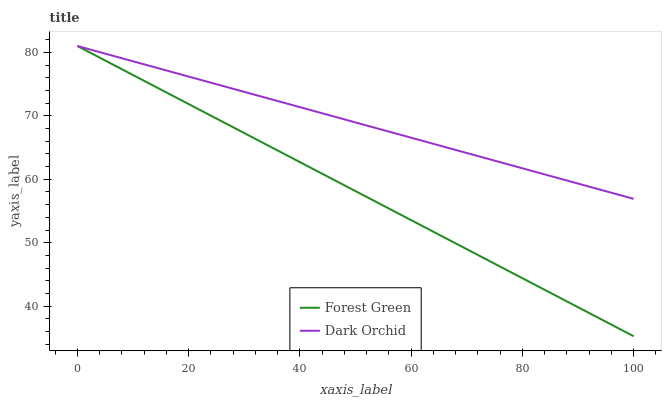Does Forest Green have the minimum area under the curve?
Answer yes or no. Yes. Does Dark Orchid have the maximum area under the curve?
Answer yes or no. Yes. Does Dark Orchid have the minimum area under the curve?
Answer yes or no. No. Is Forest Green the smoothest?
Answer yes or no. Yes. Is Dark Orchid the roughest?
Answer yes or no. Yes. Is Dark Orchid the smoothest?
Answer yes or no. No. Does Forest Green have the lowest value?
Answer yes or no. Yes. Does Dark Orchid have the lowest value?
Answer yes or no. No. Does Dark Orchid have the highest value?
Answer yes or no. Yes. Does Dark Orchid intersect Forest Green?
Answer yes or no. Yes. Is Dark Orchid less than Forest Green?
Answer yes or no. No. Is Dark Orchid greater than Forest Green?
Answer yes or no. No. 